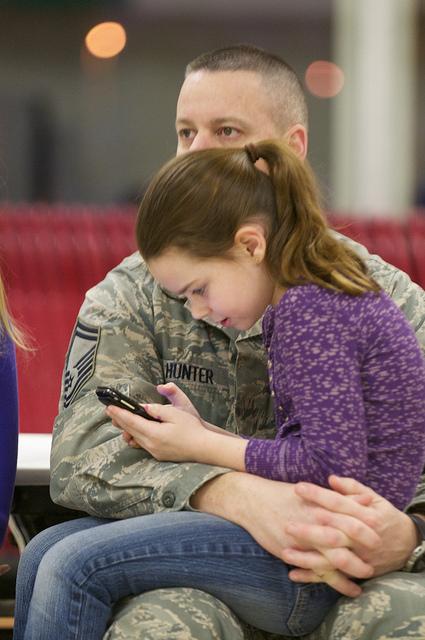Are these two people close to the same age?
Quick response, please. No. What is his last name?
Give a very brief answer. Hunter. What color is the girl's shirt?
Quick response, please. Purple. 